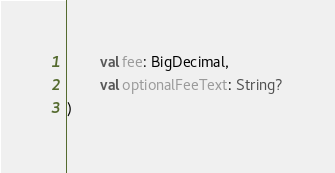Convert code to text. <code><loc_0><loc_0><loc_500><loc_500><_Kotlin_>        val fee: BigDecimal,
        val optionalFeeText: String?
)</code> 